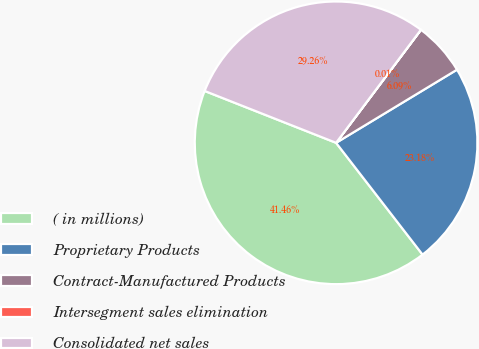Convert chart. <chart><loc_0><loc_0><loc_500><loc_500><pie_chart><fcel>( in millions)<fcel>Proprietary Products<fcel>Contract-Manufactured Products<fcel>Intersegment sales elimination<fcel>Consolidated net sales<nl><fcel>41.46%<fcel>23.18%<fcel>6.09%<fcel>0.01%<fcel>29.26%<nl></chart> 